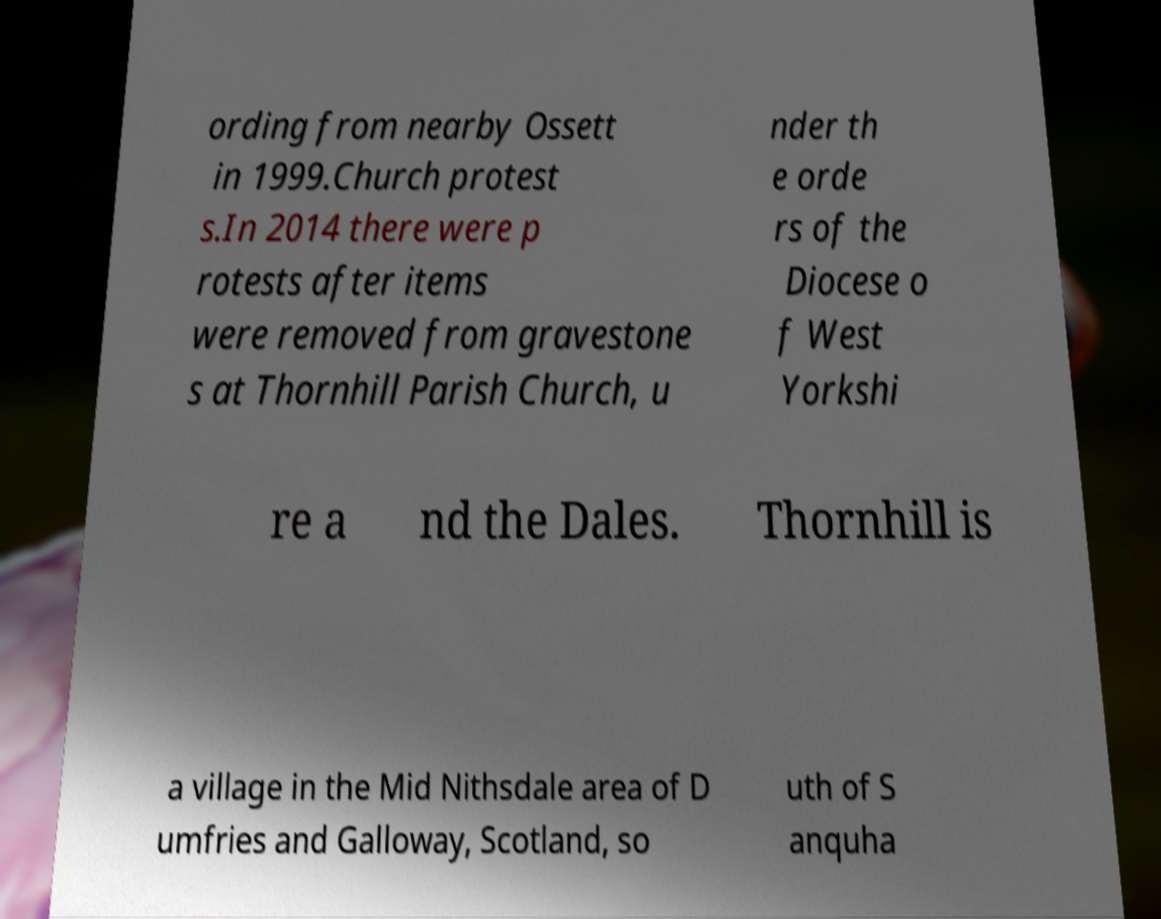What messages or text are displayed in this image? I need them in a readable, typed format. ording from nearby Ossett in 1999.Church protest s.In 2014 there were p rotests after items were removed from gravestone s at Thornhill Parish Church, u nder th e orde rs of the Diocese o f West Yorkshi re a nd the Dales. Thornhill is a village in the Mid Nithsdale area of D umfries and Galloway, Scotland, so uth of S anquha 